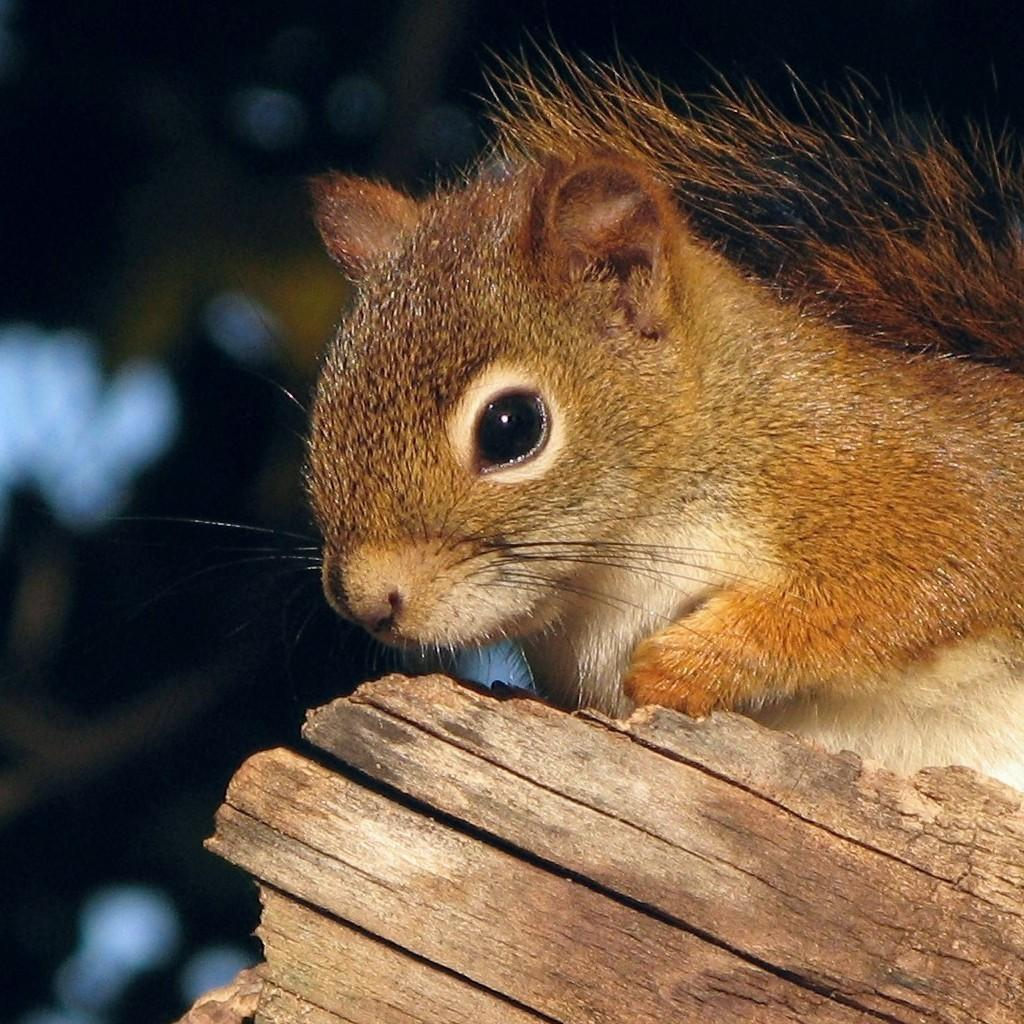What type of animal is in the image? There is a squirrel in the image. Where is the squirrel located? The squirrel is on a wooden block. How does the squirrel grant wishes in the image? The squirrel does not grant wishes in the image, as it is a squirrel and not a magical being. 